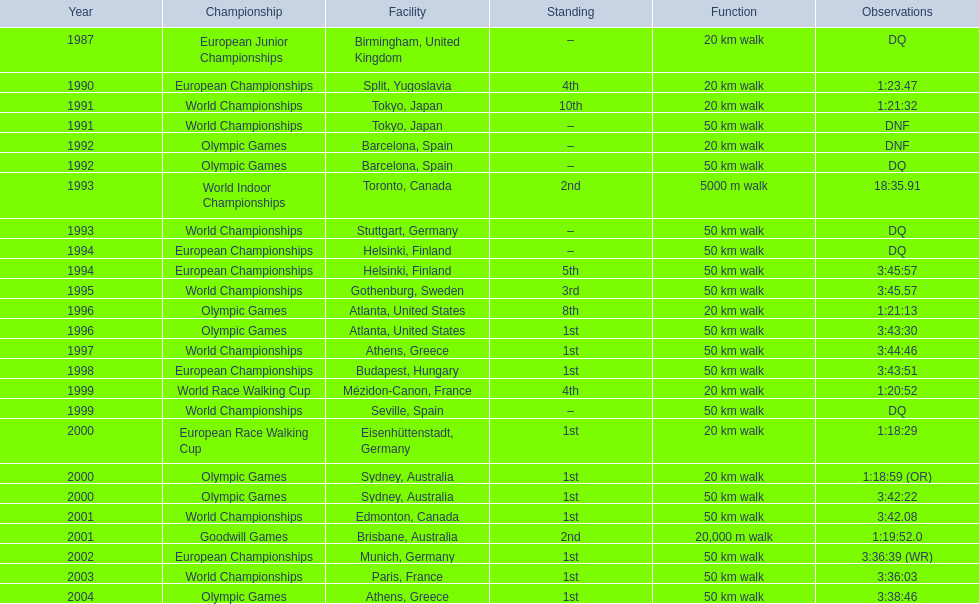In 1990 what position did robert korzeniowski place? 4th. In 1993 what was robert korzeniowski's place in the world indoor championships? 2nd. How long did the 50km walk in 2004 olympic cost? 3:38:46. 